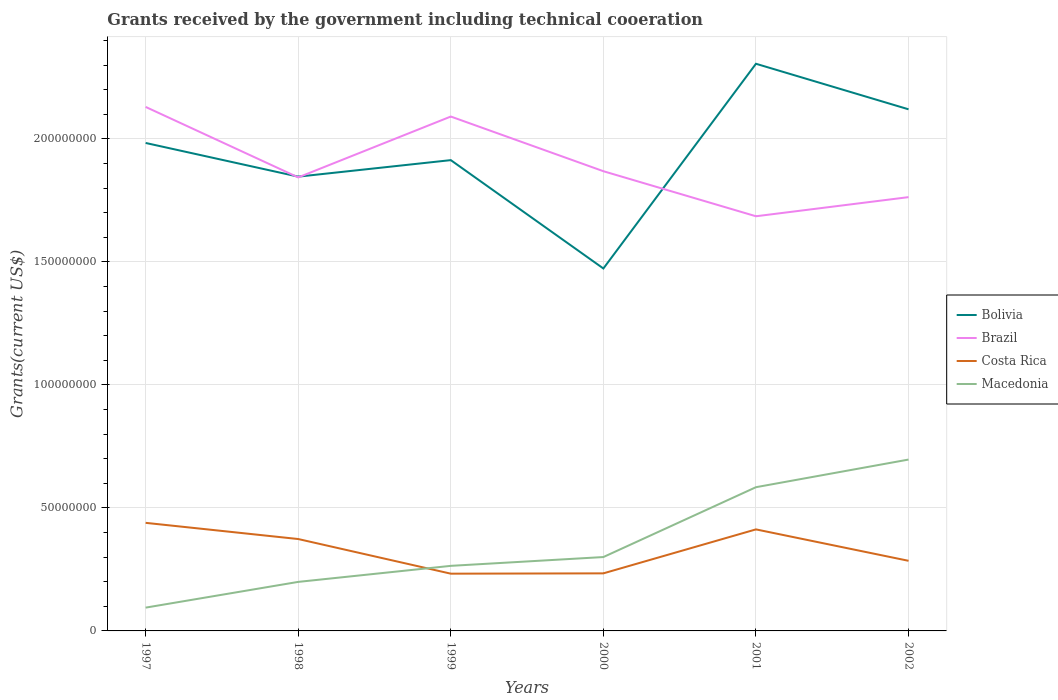Does the line corresponding to Brazil intersect with the line corresponding to Costa Rica?
Keep it short and to the point. No. Across all years, what is the maximum total grants received by the government in Brazil?
Keep it short and to the point. 1.69e+08. In which year was the total grants received by the government in Macedonia maximum?
Your response must be concise. 1997. What is the total total grants received by the government in Costa Rica in the graph?
Offer a very short reply. 1.54e+07. What is the difference between the highest and the second highest total grants received by the government in Costa Rica?
Make the answer very short. 2.07e+07. What is the difference between the highest and the lowest total grants received by the government in Macedonia?
Your answer should be compact. 2. Is the total grants received by the government in Costa Rica strictly greater than the total grants received by the government in Brazil over the years?
Give a very brief answer. Yes. How many lines are there?
Offer a terse response. 4. Are the values on the major ticks of Y-axis written in scientific E-notation?
Provide a short and direct response. No. Does the graph contain any zero values?
Offer a terse response. No. Does the graph contain grids?
Provide a short and direct response. Yes. How many legend labels are there?
Keep it short and to the point. 4. How are the legend labels stacked?
Provide a short and direct response. Vertical. What is the title of the graph?
Your response must be concise. Grants received by the government including technical cooeration. Does "Azerbaijan" appear as one of the legend labels in the graph?
Provide a short and direct response. No. What is the label or title of the X-axis?
Make the answer very short. Years. What is the label or title of the Y-axis?
Give a very brief answer. Grants(current US$). What is the Grants(current US$) in Bolivia in 1997?
Offer a terse response. 1.98e+08. What is the Grants(current US$) of Brazil in 1997?
Provide a succinct answer. 2.13e+08. What is the Grants(current US$) of Costa Rica in 1997?
Offer a very short reply. 4.39e+07. What is the Grants(current US$) of Macedonia in 1997?
Provide a succinct answer. 9.47e+06. What is the Grants(current US$) in Bolivia in 1998?
Provide a succinct answer. 1.85e+08. What is the Grants(current US$) in Brazil in 1998?
Offer a very short reply. 1.84e+08. What is the Grants(current US$) in Costa Rica in 1998?
Your answer should be very brief. 3.74e+07. What is the Grants(current US$) in Macedonia in 1998?
Your answer should be very brief. 1.99e+07. What is the Grants(current US$) in Bolivia in 1999?
Make the answer very short. 1.91e+08. What is the Grants(current US$) of Brazil in 1999?
Offer a terse response. 2.09e+08. What is the Grants(current US$) in Costa Rica in 1999?
Make the answer very short. 2.33e+07. What is the Grants(current US$) of Macedonia in 1999?
Provide a succinct answer. 2.64e+07. What is the Grants(current US$) of Bolivia in 2000?
Make the answer very short. 1.47e+08. What is the Grants(current US$) in Brazil in 2000?
Make the answer very short. 1.87e+08. What is the Grants(current US$) in Costa Rica in 2000?
Provide a short and direct response. 2.34e+07. What is the Grants(current US$) of Macedonia in 2000?
Give a very brief answer. 3.00e+07. What is the Grants(current US$) in Bolivia in 2001?
Offer a very short reply. 2.31e+08. What is the Grants(current US$) of Brazil in 2001?
Give a very brief answer. 1.69e+08. What is the Grants(current US$) of Costa Rica in 2001?
Provide a short and direct response. 4.13e+07. What is the Grants(current US$) of Macedonia in 2001?
Offer a very short reply. 5.84e+07. What is the Grants(current US$) of Bolivia in 2002?
Your response must be concise. 2.12e+08. What is the Grants(current US$) in Brazil in 2002?
Make the answer very short. 1.76e+08. What is the Grants(current US$) in Costa Rica in 2002?
Provide a succinct answer. 2.85e+07. What is the Grants(current US$) in Macedonia in 2002?
Provide a succinct answer. 6.96e+07. Across all years, what is the maximum Grants(current US$) of Bolivia?
Your answer should be compact. 2.31e+08. Across all years, what is the maximum Grants(current US$) of Brazil?
Ensure brevity in your answer.  2.13e+08. Across all years, what is the maximum Grants(current US$) in Costa Rica?
Offer a very short reply. 4.39e+07. Across all years, what is the maximum Grants(current US$) in Macedonia?
Provide a short and direct response. 6.96e+07. Across all years, what is the minimum Grants(current US$) in Bolivia?
Give a very brief answer. 1.47e+08. Across all years, what is the minimum Grants(current US$) of Brazil?
Provide a succinct answer. 1.69e+08. Across all years, what is the minimum Grants(current US$) of Costa Rica?
Offer a terse response. 2.33e+07. Across all years, what is the minimum Grants(current US$) of Macedonia?
Provide a succinct answer. 9.47e+06. What is the total Grants(current US$) in Bolivia in the graph?
Ensure brevity in your answer.  1.16e+09. What is the total Grants(current US$) of Brazil in the graph?
Make the answer very short. 1.14e+09. What is the total Grants(current US$) of Costa Rica in the graph?
Offer a very short reply. 1.98e+08. What is the total Grants(current US$) of Macedonia in the graph?
Make the answer very short. 2.14e+08. What is the difference between the Grants(current US$) in Bolivia in 1997 and that in 1998?
Make the answer very short. 1.37e+07. What is the difference between the Grants(current US$) in Brazil in 1997 and that in 1998?
Give a very brief answer. 2.86e+07. What is the difference between the Grants(current US$) of Costa Rica in 1997 and that in 1998?
Make the answer very short. 6.58e+06. What is the difference between the Grants(current US$) in Macedonia in 1997 and that in 1998?
Give a very brief answer. -1.05e+07. What is the difference between the Grants(current US$) in Bolivia in 1997 and that in 1999?
Give a very brief answer. 6.98e+06. What is the difference between the Grants(current US$) in Brazil in 1997 and that in 1999?
Keep it short and to the point. 3.91e+06. What is the difference between the Grants(current US$) in Costa Rica in 1997 and that in 1999?
Make the answer very short. 2.07e+07. What is the difference between the Grants(current US$) in Macedonia in 1997 and that in 1999?
Offer a very short reply. -1.70e+07. What is the difference between the Grants(current US$) in Bolivia in 1997 and that in 2000?
Provide a succinct answer. 5.10e+07. What is the difference between the Grants(current US$) of Brazil in 1997 and that in 2000?
Your response must be concise. 2.61e+07. What is the difference between the Grants(current US$) in Costa Rica in 1997 and that in 2000?
Offer a terse response. 2.05e+07. What is the difference between the Grants(current US$) of Macedonia in 1997 and that in 2000?
Give a very brief answer. -2.06e+07. What is the difference between the Grants(current US$) in Bolivia in 1997 and that in 2001?
Provide a short and direct response. -3.22e+07. What is the difference between the Grants(current US$) in Brazil in 1997 and that in 2001?
Make the answer very short. 4.44e+07. What is the difference between the Grants(current US$) in Costa Rica in 1997 and that in 2001?
Give a very brief answer. 2.66e+06. What is the difference between the Grants(current US$) in Macedonia in 1997 and that in 2001?
Give a very brief answer. -4.90e+07. What is the difference between the Grants(current US$) in Bolivia in 1997 and that in 2002?
Ensure brevity in your answer.  -1.37e+07. What is the difference between the Grants(current US$) in Brazil in 1997 and that in 2002?
Offer a terse response. 3.67e+07. What is the difference between the Grants(current US$) of Costa Rica in 1997 and that in 2002?
Give a very brief answer. 1.54e+07. What is the difference between the Grants(current US$) in Macedonia in 1997 and that in 2002?
Provide a succinct answer. -6.02e+07. What is the difference between the Grants(current US$) of Bolivia in 1998 and that in 1999?
Give a very brief answer. -6.71e+06. What is the difference between the Grants(current US$) of Brazil in 1998 and that in 1999?
Make the answer very short. -2.47e+07. What is the difference between the Grants(current US$) of Costa Rica in 1998 and that in 1999?
Your response must be concise. 1.41e+07. What is the difference between the Grants(current US$) in Macedonia in 1998 and that in 1999?
Keep it short and to the point. -6.52e+06. What is the difference between the Grants(current US$) in Bolivia in 1998 and that in 2000?
Your response must be concise. 3.73e+07. What is the difference between the Grants(current US$) in Brazil in 1998 and that in 2000?
Make the answer very short. -2.52e+06. What is the difference between the Grants(current US$) of Costa Rica in 1998 and that in 2000?
Provide a short and direct response. 1.40e+07. What is the difference between the Grants(current US$) in Macedonia in 1998 and that in 2000?
Provide a short and direct response. -1.01e+07. What is the difference between the Grants(current US$) of Bolivia in 1998 and that in 2001?
Your answer should be very brief. -4.59e+07. What is the difference between the Grants(current US$) in Brazil in 1998 and that in 2001?
Provide a succinct answer. 1.58e+07. What is the difference between the Grants(current US$) of Costa Rica in 1998 and that in 2001?
Offer a terse response. -3.92e+06. What is the difference between the Grants(current US$) in Macedonia in 1998 and that in 2001?
Keep it short and to the point. -3.85e+07. What is the difference between the Grants(current US$) in Bolivia in 1998 and that in 2002?
Provide a succinct answer. -2.74e+07. What is the difference between the Grants(current US$) of Brazil in 1998 and that in 2002?
Your answer should be compact. 8.02e+06. What is the difference between the Grants(current US$) of Costa Rica in 1998 and that in 2002?
Offer a very short reply. 8.85e+06. What is the difference between the Grants(current US$) in Macedonia in 1998 and that in 2002?
Make the answer very short. -4.97e+07. What is the difference between the Grants(current US$) of Bolivia in 1999 and that in 2000?
Keep it short and to the point. 4.40e+07. What is the difference between the Grants(current US$) in Brazil in 1999 and that in 2000?
Your response must be concise. 2.22e+07. What is the difference between the Grants(current US$) of Costa Rica in 1999 and that in 2000?
Provide a succinct answer. -1.30e+05. What is the difference between the Grants(current US$) of Macedonia in 1999 and that in 2000?
Ensure brevity in your answer.  -3.58e+06. What is the difference between the Grants(current US$) of Bolivia in 1999 and that in 2001?
Provide a short and direct response. -3.92e+07. What is the difference between the Grants(current US$) of Brazil in 1999 and that in 2001?
Your answer should be compact. 4.05e+07. What is the difference between the Grants(current US$) of Costa Rica in 1999 and that in 2001?
Your answer should be very brief. -1.80e+07. What is the difference between the Grants(current US$) in Macedonia in 1999 and that in 2001?
Ensure brevity in your answer.  -3.20e+07. What is the difference between the Grants(current US$) of Bolivia in 1999 and that in 2002?
Offer a terse response. -2.07e+07. What is the difference between the Grants(current US$) in Brazil in 1999 and that in 2002?
Keep it short and to the point. 3.28e+07. What is the difference between the Grants(current US$) of Costa Rica in 1999 and that in 2002?
Your response must be concise. -5.23e+06. What is the difference between the Grants(current US$) of Macedonia in 1999 and that in 2002?
Provide a succinct answer. -4.32e+07. What is the difference between the Grants(current US$) in Bolivia in 2000 and that in 2001?
Give a very brief answer. -8.32e+07. What is the difference between the Grants(current US$) in Brazil in 2000 and that in 2001?
Ensure brevity in your answer.  1.83e+07. What is the difference between the Grants(current US$) of Costa Rica in 2000 and that in 2001?
Offer a very short reply. -1.79e+07. What is the difference between the Grants(current US$) of Macedonia in 2000 and that in 2001?
Keep it short and to the point. -2.84e+07. What is the difference between the Grants(current US$) of Bolivia in 2000 and that in 2002?
Offer a terse response. -6.47e+07. What is the difference between the Grants(current US$) of Brazil in 2000 and that in 2002?
Your answer should be very brief. 1.05e+07. What is the difference between the Grants(current US$) of Costa Rica in 2000 and that in 2002?
Your answer should be very brief. -5.10e+06. What is the difference between the Grants(current US$) in Macedonia in 2000 and that in 2002?
Keep it short and to the point. -3.96e+07. What is the difference between the Grants(current US$) in Bolivia in 2001 and that in 2002?
Provide a short and direct response. 1.85e+07. What is the difference between the Grants(current US$) of Brazil in 2001 and that in 2002?
Your answer should be very brief. -7.77e+06. What is the difference between the Grants(current US$) of Costa Rica in 2001 and that in 2002?
Make the answer very short. 1.28e+07. What is the difference between the Grants(current US$) in Macedonia in 2001 and that in 2002?
Give a very brief answer. -1.12e+07. What is the difference between the Grants(current US$) in Bolivia in 1997 and the Grants(current US$) in Brazil in 1998?
Give a very brief answer. 1.40e+07. What is the difference between the Grants(current US$) of Bolivia in 1997 and the Grants(current US$) of Costa Rica in 1998?
Make the answer very short. 1.61e+08. What is the difference between the Grants(current US$) of Bolivia in 1997 and the Grants(current US$) of Macedonia in 1998?
Make the answer very short. 1.78e+08. What is the difference between the Grants(current US$) in Brazil in 1997 and the Grants(current US$) in Costa Rica in 1998?
Offer a very short reply. 1.76e+08. What is the difference between the Grants(current US$) of Brazil in 1997 and the Grants(current US$) of Macedonia in 1998?
Keep it short and to the point. 1.93e+08. What is the difference between the Grants(current US$) of Costa Rica in 1997 and the Grants(current US$) of Macedonia in 1998?
Your response must be concise. 2.40e+07. What is the difference between the Grants(current US$) in Bolivia in 1997 and the Grants(current US$) in Brazil in 1999?
Your response must be concise. -1.07e+07. What is the difference between the Grants(current US$) of Bolivia in 1997 and the Grants(current US$) of Costa Rica in 1999?
Keep it short and to the point. 1.75e+08. What is the difference between the Grants(current US$) in Bolivia in 1997 and the Grants(current US$) in Macedonia in 1999?
Your response must be concise. 1.72e+08. What is the difference between the Grants(current US$) in Brazil in 1997 and the Grants(current US$) in Costa Rica in 1999?
Give a very brief answer. 1.90e+08. What is the difference between the Grants(current US$) in Brazil in 1997 and the Grants(current US$) in Macedonia in 1999?
Your answer should be compact. 1.87e+08. What is the difference between the Grants(current US$) of Costa Rica in 1997 and the Grants(current US$) of Macedonia in 1999?
Your response must be concise. 1.75e+07. What is the difference between the Grants(current US$) in Bolivia in 1997 and the Grants(current US$) in Brazil in 2000?
Your answer should be very brief. 1.15e+07. What is the difference between the Grants(current US$) in Bolivia in 1997 and the Grants(current US$) in Costa Rica in 2000?
Provide a succinct answer. 1.75e+08. What is the difference between the Grants(current US$) of Bolivia in 1997 and the Grants(current US$) of Macedonia in 2000?
Ensure brevity in your answer.  1.68e+08. What is the difference between the Grants(current US$) in Brazil in 1997 and the Grants(current US$) in Costa Rica in 2000?
Ensure brevity in your answer.  1.90e+08. What is the difference between the Grants(current US$) of Brazil in 1997 and the Grants(current US$) of Macedonia in 2000?
Offer a terse response. 1.83e+08. What is the difference between the Grants(current US$) in Costa Rica in 1997 and the Grants(current US$) in Macedonia in 2000?
Ensure brevity in your answer.  1.39e+07. What is the difference between the Grants(current US$) of Bolivia in 1997 and the Grants(current US$) of Brazil in 2001?
Make the answer very short. 2.98e+07. What is the difference between the Grants(current US$) of Bolivia in 1997 and the Grants(current US$) of Costa Rica in 2001?
Provide a succinct answer. 1.57e+08. What is the difference between the Grants(current US$) in Bolivia in 1997 and the Grants(current US$) in Macedonia in 2001?
Make the answer very short. 1.40e+08. What is the difference between the Grants(current US$) of Brazil in 1997 and the Grants(current US$) of Costa Rica in 2001?
Your answer should be compact. 1.72e+08. What is the difference between the Grants(current US$) in Brazil in 1997 and the Grants(current US$) in Macedonia in 2001?
Give a very brief answer. 1.55e+08. What is the difference between the Grants(current US$) in Costa Rica in 1997 and the Grants(current US$) in Macedonia in 2001?
Provide a short and direct response. -1.45e+07. What is the difference between the Grants(current US$) of Bolivia in 1997 and the Grants(current US$) of Brazil in 2002?
Offer a terse response. 2.20e+07. What is the difference between the Grants(current US$) of Bolivia in 1997 and the Grants(current US$) of Costa Rica in 2002?
Ensure brevity in your answer.  1.70e+08. What is the difference between the Grants(current US$) in Bolivia in 1997 and the Grants(current US$) in Macedonia in 2002?
Provide a short and direct response. 1.29e+08. What is the difference between the Grants(current US$) in Brazil in 1997 and the Grants(current US$) in Costa Rica in 2002?
Offer a very short reply. 1.84e+08. What is the difference between the Grants(current US$) in Brazil in 1997 and the Grants(current US$) in Macedonia in 2002?
Provide a short and direct response. 1.43e+08. What is the difference between the Grants(current US$) in Costa Rica in 1997 and the Grants(current US$) in Macedonia in 2002?
Your response must be concise. -2.57e+07. What is the difference between the Grants(current US$) in Bolivia in 1998 and the Grants(current US$) in Brazil in 1999?
Provide a short and direct response. -2.44e+07. What is the difference between the Grants(current US$) in Bolivia in 1998 and the Grants(current US$) in Costa Rica in 1999?
Offer a terse response. 1.61e+08. What is the difference between the Grants(current US$) of Bolivia in 1998 and the Grants(current US$) of Macedonia in 1999?
Ensure brevity in your answer.  1.58e+08. What is the difference between the Grants(current US$) of Brazil in 1998 and the Grants(current US$) of Costa Rica in 1999?
Offer a very short reply. 1.61e+08. What is the difference between the Grants(current US$) in Brazil in 1998 and the Grants(current US$) in Macedonia in 1999?
Give a very brief answer. 1.58e+08. What is the difference between the Grants(current US$) of Costa Rica in 1998 and the Grants(current US$) of Macedonia in 1999?
Ensure brevity in your answer.  1.09e+07. What is the difference between the Grants(current US$) of Bolivia in 1998 and the Grants(current US$) of Brazil in 2000?
Keep it short and to the point. -2.21e+06. What is the difference between the Grants(current US$) in Bolivia in 1998 and the Grants(current US$) in Costa Rica in 2000?
Provide a succinct answer. 1.61e+08. What is the difference between the Grants(current US$) in Bolivia in 1998 and the Grants(current US$) in Macedonia in 2000?
Your answer should be compact. 1.55e+08. What is the difference between the Grants(current US$) in Brazil in 1998 and the Grants(current US$) in Costa Rica in 2000?
Your response must be concise. 1.61e+08. What is the difference between the Grants(current US$) in Brazil in 1998 and the Grants(current US$) in Macedonia in 2000?
Ensure brevity in your answer.  1.54e+08. What is the difference between the Grants(current US$) in Costa Rica in 1998 and the Grants(current US$) in Macedonia in 2000?
Keep it short and to the point. 7.32e+06. What is the difference between the Grants(current US$) of Bolivia in 1998 and the Grants(current US$) of Brazil in 2001?
Provide a short and direct response. 1.61e+07. What is the difference between the Grants(current US$) of Bolivia in 1998 and the Grants(current US$) of Costa Rica in 2001?
Ensure brevity in your answer.  1.43e+08. What is the difference between the Grants(current US$) of Bolivia in 1998 and the Grants(current US$) of Macedonia in 2001?
Keep it short and to the point. 1.26e+08. What is the difference between the Grants(current US$) of Brazil in 1998 and the Grants(current US$) of Costa Rica in 2001?
Give a very brief answer. 1.43e+08. What is the difference between the Grants(current US$) in Brazil in 1998 and the Grants(current US$) in Macedonia in 2001?
Keep it short and to the point. 1.26e+08. What is the difference between the Grants(current US$) of Costa Rica in 1998 and the Grants(current US$) of Macedonia in 2001?
Provide a succinct answer. -2.11e+07. What is the difference between the Grants(current US$) of Bolivia in 1998 and the Grants(current US$) of Brazil in 2002?
Give a very brief answer. 8.33e+06. What is the difference between the Grants(current US$) in Bolivia in 1998 and the Grants(current US$) in Costa Rica in 2002?
Your answer should be compact. 1.56e+08. What is the difference between the Grants(current US$) of Bolivia in 1998 and the Grants(current US$) of Macedonia in 2002?
Your answer should be compact. 1.15e+08. What is the difference between the Grants(current US$) in Brazil in 1998 and the Grants(current US$) in Costa Rica in 2002?
Provide a succinct answer. 1.56e+08. What is the difference between the Grants(current US$) in Brazil in 1998 and the Grants(current US$) in Macedonia in 2002?
Ensure brevity in your answer.  1.15e+08. What is the difference between the Grants(current US$) of Costa Rica in 1998 and the Grants(current US$) of Macedonia in 2002?
Provide a short and direct response. -3.23e+07. What is the difference between the Grants(current US$) of Bolivia in 1999 and the Grants(current US$) of Brazil in 2000?
Keep it short and to the point. 4.50e+06. What is the difference between the Grants(current US$) in Bolivia in 1999 and the Grants(current US$) in Costa Rica in 2000?
Give a very brief answer. 1.68e+08. What is the difference between the Grants(current US$) in Bolivia in 1999 and the Grants(current US$) in Macedonia in 2000?
Ensure brevity in your answer.  1.61e+08. What is the difference between the Grants(current US$) in Brazil in 1999 and the Grants(current US$) in Costa Rica in 2000?
Your answer should be compact. 1.86e+08. What is the difference between the Grants(current US$) in Brazil in 1999 and the Grants(current US$) in Macedonia in 2000?
Keep it short and to the point. 1.79e+08. What is the difference between the Grants(current US$) of Costa Rica in 1999 and the Grants(current US$) of Macedonia in 2000?
Provide a short and direct response. -6.76e+06. What is the difference between the Grants(current US$) of Bolivia in 1999 and the Grants(current US$) of Brazil in 2001?
Provide a short and direct response. 2.28e+07. What is the difference between the Grants(current US$) of Bolivia in 1999 and the Grants(current US$) of Costa Rica in 2001?
Give a very brief answer. 1.50e+08. What is the difference between the Grants(current US$) of Bolivia in 1999 and the Grants(current US$) of Macedonia in 2001?
Ensure brevity in your answer.  1.33e+08. What is the difference between the Grants(current US$) of Brazil in 1999 and the Grants(current US$) of Costa Rica in 2001?
Provide a succinct answer. 1.68e+08. What is the difference between the Grants(current US$) of Brazil in 1999 and the Grants(current US$) of Macedonia in 2001?
Keep it short and to the point. 1.51e+08. What is the difference between the Grants(current US$) of Costa Rica in 1999 and the Grants(current US$) of Macedonia in 2001?
Your answer should be very brief. -3.52e+07. What is the difference between the Grants(current US$) in Bolivia in 1999 and the Grants(current US$) in Brazil in 2002?
Provide a short and direct response. 1.50e+07. What is the difference between the Grants(current US$) of Bolivia in 1999 and the Grants(current US$) of Costa Rica in 2002?
Offer a terse response. 1.63e+08. What is the difference between the Grants(current US$) of Bolivia in 1999 and the Grants(current US$) of Macedonia in 2002?
Ensure brevity in your answer.  1.22e+08. What is the difference between the Grants(current US$) in Brazil in 1999 and the Grants(current US$) in Costa Rica in 2002?
Offer a very short reply. 1.81e+08. What is the difference between the Grants(current US$) in Brazil in 1999 and the Grants(current US$) in Macedonia in 2002?
Your response must be concise. 1.39e+08. What is the difference between the Grants(current US$) of Costa Rica in 1999 and the Grants(current US$) of Macedonia in 2002?
Provide a succinct answer. -4.64e+07. What is the difference between the Grants(current US$) in Bolivia in 2000 and the Grants(current US$) in Brazil in 2001?
Provide a short and direct response. -2.12e+07. What is the difference between the Grants(current US$) of Bolivia in 2000 and the Grants(current US$) of Costa Rica in 2001?
Ensure brevity in your answer.  1.06e+08. What is the difference between the Grants(current US$) in Bolivia in 2000 and the Grants(current US$) in Macedonia in 2001?
Give a very brief answer. 8.89e+07. What is the difference between the Grants(current US$) of Brazil in 2000 and the Grants(current US$) of Costa Rica in 2001?
Your answer should be compact. 1.46e+08. What is the difference between the Grants(current US$) in Brazil in 2000 and the Grants(current US$) in Macedonia in 2001?
Your answer should be very brief. 1.28e+08. What is the difference between the Grants(current US$) of Costa Rica in 2000 and the Grants(current US$) of Macedonia in 2001?
Offer a very short reply. -3.50e+07. What is the difference between the Grants(current US$) of Bolivia in 2000 and the Grants(current US$) of Brazil in 2002?
Your answer should be compact. -2.90e+07. What is the difference between the Grants(current US$) in Bolivia in 2000 and the Grants(current US$) in Costa Rica in 2002?
Your answer should be very brief. 1.19e+08. What is the difference between the Grants(current US$) in Bolivia in 2000 and the Grants(current US$) in Macedonia in 2002?
Keep it short and to the point. 7.77e+07. What is the difference between the Grants(current US$) in Brazil in 2000 and the Grants(current US$) in Costa Rica in 2002?
Make the answer very short. 1.58e+08. What is the difference between the Grants(current US$) of Brazil in 2000 and the Grants(current US$) of Macedonia in 2002?
Provide a succinct answer. 1.17e+08. What is the difference between the Grants(current US$) of Costa Rica in 2000 and the Grants(current US$) of Macedonia in 2002?
Your answer should be very brief. -4.62e+07. What is the difference between the Grants(current US$) in Bolivia in 2001 and the Grants(current US$) in Brazil in 2002?
Make the answer very short. 5.42e+07. What is the difference between the Grants(current US$) in Bolivia in 2001 and the Grants(current US$) in Costa Rica in 2002?
Give a very brief answer. 2.02e+08. What is the difference between the Grants(current US$) in Bolivia in 2001 and the Grants(current US$) in Macedonia in 2002?
Offer a terse response. 1.61e+08. What is the difference between the Grants(current US$) in Brazil in 2001 and the Grants(current US$) in Costa Rica in 2002?
Offer a very short reply. 1.40e+08. What is the difference between the Grants(current US$) of Brazil in 2001 and the Grants(current US$) of Macedonia in 2002?
Make the answer very short. 9.89e+07. What is the difference between the Grants(current US$) of Costa Rica in 2001 and the Grants(current US$) of Macedonia in 2002?
Your answer should be very brief. -2.84e+07. What is the average Grants(current US$) of Bolivia per year?
Ensure brevity in your answer.  1.94e+08. What is the average Grants(current US$) in Brazil per year?
Ensure brevity in your answer.  1.90e+08. What is the average Grants(current US$) in Costa Rica per year?
Your response must be concise. 3.30e+07. What is the average Grants(current US$) of Macedonia per year?
Keep it short and to the point. 3.57e+07. In the year 1997, what is the difference between the Grants(current US$) in Bolivia and Grants(current US$) in Brazil?
Your response must be concise. -1.46e+07. In the year 1997, what is the difference between the Grants(current US$) in Bolivia and Grants(current US$) in Costa Rica?
Your answer should be compact. 1.54e+08. In the year 1997, what is the difference between the Grants(current US$) of Bolivia and Grants(current US$) of Macedonia?
Make the answer very short. 1.89e+08. In the year 1997, what is the difference between the Grants(current US$) of Brazil and Grants(current US$) of Costa Rica?
Offer a very short reply. 1.69e+08. In the year 1997, what is the difference between the Grants(current US$) of Brazil and Grants(current US$) of Macedonia?
Your answer should be compact. 2.04e+08. In the year 1997, what is the difference between the Grants(current US$) in Costa Rica and Grants(current US$) in Macedonia?
Give a very brief answer. 3.45e+07. In the year 1998, what is the difference between the Grants(current US$) of Bolivia and Grants(current US$) of Costa Rica?
Ensure brevity in your answer.  1.47e+08. In the year 1998, what is the difference between the Grants(current US$) in Bolivia and Grants(current US$) in Macedonia?
Keep it short and to the point. 1.65e+08. In the year 1998, what is the difference between the Grants(current US$) of Brazil and Grants(current US$) of Costa Rica?
Give a very brief answer. 1.47e+08. In the year 1998, what is the difference between the Grants(current US$) in Brazil and Grants(current US$) in Macedonia?
Give a very brief answer. 1.64e+08. In the year 1998, what is the difference between the Grants(current US$) of Costa Rica and Grants(current US$) of Macedonia?
Your answer should be very brief. 1.74e+07. In the year 1999, what is the difference between the Grants(current US$) in Bolivia and Grants(current US$) in Brazil?
Provide a short and direct response. -1.77e+07. In the year 1999, what is the difference between the Grants(current US$) in Bolivia and Grants(current US$) in Costa Rica?
Offer a very short reply. 1.68e+08. In the year 1999, what is the difference between the Grants(current US$) of Bolivia and Grants(current US$) of Macedonia?
Offer a very short reply. 1.65e+08. In the year 1999, what is the difference between the Grants(current US$) in Brazil and Grants(current US$) in Costa Rica?
Provide a succinct answer. 1.86e+08. In the year 1999, what is the difference between the Grants(current US$) of Brazil and Grants(current US$) of Macedonia?
Provide a short and direct response. 1.83e+08. In the year 1999, what is the difference between the Grants(current US$) in Costa Rica and Grants(current US$) in Macedonia?
Give a very brief answer. -3.18e+06. In the year 2000, what is the difference between the Grants(current US$) of Bolivia and Grants(current US$) of Brazil?
Provide a short and direct response. -3.95e+07. In the year 2000, what is the difference between the Grants(current US$) of Bolivia and Grants(current US$) of Costa Rica?
Give a very brief answer. 1.24e+08. In the year 2000, what is the difference between the Grants(current US$) of Bolivia and Grants(current US$) of Macedonia?
Provide a short and direct response. 1.17e+08. In the year 2000, what is the difference between the Grants(current US$) of Brazil and Grants(current US$) of Costa Rica?
Offer a terse response. 1.63e+08. In the year 2000, what is the difference between the Grants(current US$) in Brazil and Grants(current US$) in Macedonia?
Make the answer very short. 1.57e+08. In the year 2000, what is the difference between the Grants(current US$) in Costa Rica and Grants(current US$) in Macedonia?
Provide a succinct answer. -6.63e+06. In the year 2001, what is the difference between the Grants(current US$) in Bolivia and Grants(current US$) in Brazil?
Offer a very short reply. 6.20e+07. In the year 2001, what is the difference between the Grants(current US$) in Bolivia and Grants(current US$) in Costa Rica?
Your answer should be very brief. 1.89e+08. In the year 2001, what is the difference between the Grants(current US$) of Bolivia and Grants(current US$) of Macedonia?
Offer a terse response. 1.72e+08. In the year 2001, what is the difference between the Grants(current US$) in Brazil and Grants(current US$) in Costa Rica?
Offer a very short reply. 1.27e+08. In the year 2001, what is the difference between the Grants(current US$) of Brazil and Grants(current US$) of Macedonia?
Make the answer very short. 1.10e+08. In the year 2001, what is the difference between the Grants(current US$) in Costa Rica and Grants(current US$) in Macedonia?
Provide a short and direct response. -1.72e+07. In the year 2002, what is the difference between the Grants(current US$) of Bolivia and Grants(current US$) of Brazil?
Offer a very short reply. 3.57e+07. In the year 2002, what is the difference between the Grants(current US$) of Bolivia and Grants(current US$) of Costa Rica?
Give a very brief answer. 1.84e+08. In the year 2002, what is the difference between the Grants(current US$) of Bolivia and Grants(current US$) of Macedonia?
Keep it short and to the point. 1.42e+08. In the year 2002, what is the difference between the Grants(current US$) of Brazil and Grants(current US$) of Costa Rica?
Offer a terse response. 1.48e+08. In the year 2002, what is the difference between the Grants(current US$) in Brazil and Grants(current US$) in Macedonia?
Your response must be concise. 1.07e+08. In the year 2002, what is the difference between the Grants(current US$) in Costa Rica and Grants(current US$) in Macedonia?
Offer a very short reply. -4.12e+07. What is the ratio of the Grants(current US$) of Bolivia in 1997 to that in 1998?
Your answer should be compact. 1.07. What is the ratio of the Grants(current US$) of Brazil in 1997 to that in 1998?
Give a very brief answer. 1.16. What is the ratio of the Grants(current US$) in Costa Rica in 1997 to that in 1998?
Keep it short and to the point. 1.18. What is the ratio of the Grants(current US$) in Macedonia in 1997 to that in 1998?
Keep it short and to the point. 0.48. What is the ratio of the Grants(current US$) in Bolivia in 1997 to that in 1999?
Provide a short and direct response. 1.04. What is the ratio of the Grants(current US$) in Brazil in 1997 to that in 1999?
Keep it short and to the point. 1.02. What is the ratio of the Grants(current US$) in Costa Rica in 1997 to that in 1999?
Your answer should be compact. 1.89. What is the ratio of the Grants(current US$) of Macedonia in 1997 to that in 1999?
Make the answer very short. 0.36. What is the ratio of the Grants(current US$) of Bolivia in 1997 to that in 2000?
Offer a very short reply. 1.35. What is the ratio of the Grants(current US$) in Brazil in 1997 to that in 2000?
Make the answer very short. 1.14. What is the ratio of the Grants(current US$) in Costa Rica in 1997 to that in 2000?
Ensure brevity in your answer.  1.88. What is the ratio of the Grants(current US$) of Macedonia in 1997 to that in 2000?
Ensure brevity in your answer.  0.32. What is the ratio of the Grants(current US$) in Bolivia in 1997 to that in 2001?
Your answer should be very brief. 0.86. What is the ratio of the Grants(current US$) in Brazil in 1997 to that in 2001?
Your answer should be very brief. 1.26. What is the ratio of the Grants(current US$) of Costa Rica in 1997 to that in 2001?
Your response must be concise. 1.06. What is the ratio of the Grants(current US$) in Macedonia in 1997 to that in 2001?
Offer a very short reply. 0.16. What is the ratio of the Grants(current US$) in Bolivia in 1997 to that in 2002?
Ensure brevity in your answer.  0.94. What is the ratio of the Grants(current US$) of Brazil in 1997 to that in 2002?
Give a very brief answer. 1.21. What is the ratio of the Grants(current US$) of Costa Rica in 1997 to that in 2002?
Your answer should be very brief. 1.54. What is the ratio of the Grants(current US$) in Macedonia in 1997 to that in 2002?
Keep it short and to the point. 0.14. What is the ratio of the Grants(current US$) in Bolivia in 1998 to that in 1999?
Provide a succinct answer. 0.96. What is the ratio of the Grants(current US$) in Brazil in 1998 to that in 1999?
Offer a very short reply. 0.88. What is the ratio of the Grants(current US$) of Costa Rica in 1998 to that in 1999?
Your answer should be very brief. 1.61. What is the ratio of the Grants(current US$) in Macedonia in 1998 to that in 1999?
Ensure brevity in your answer.  0.75. What is the ratio of the Grants(current US$) in Bolivia in 1998 to that in 2000?
Your answer should be compact. 1.25. What is the ratio of the Grants(current US$) in Brazil in 1998 to that in 2000?
Your answer should be very brief. 0.99. What is the ratio of the Grants(current US$) of Costa Rica in 1998 to that in 2000?
Your answer should be compact. 1.6. What is the ratio of the Grants(current US$) in Macedonia in 1998 to that in 2000?
Your response must be concise. 0.66. What is the ratio of the Grants(current US$) in Bolivia in 1998 to that in 2001?
Ensure brevity in your answer.  0.8. What is the ratio of the Grants(current US$) in Brazil in 1998 to that in 2001?
Offer a terse response. 1.09. What is the ratio of the Grants(current US$) of Costa Rica in 1998 to that in 2001?
Offer a terse response. 0.91. What is the ratio of the Grants(current US$) in Macedonia in 1998 to that in 2001?
Your answer should be compact. 0.34. What is the ratio of the Grants(current US$) of Bolivia in 1998 to that in 2002?
Keep it short and to the point. 0.87. What is the ratio of the Grants(current US$) in Brazil in 1998 to that in 2002?
Provide a short and direct response. 1.05. What is the ratio of the Grants(current US$) in Costa Rica in 1998 to that in 2002?
Keep it short and to the point. 1.31. What is the ratio of the Grants(current US$) in Macedonia in 1998 to that in 2002?
Ensure brevity in your answer.  0.29. What is the ratio of the Grants(current US$) in Bolivia in 1999 to that in 2000?
Keep it short and to the point. 1.3. What is the ratio of the Grants(current US$) in Brazil in 1999 to that in 2000?
Offer a terse response. 1.12. What is the ratio of the Grants(current US$) of Macedonia in 1999 to that in 2000?
Make the answer very short. 0.88. What is the ratio of the Grants(current US$) in Bolivia in 1999 to that in 2001?
Give a very brief answer. 0.83. What is the ratio of the Grants(current US$) of Brazil in 1999 to that in 2001?
Your response must be concise. 1.24. What is the ratio of the Grants(current US$) of Costa Rica in 1999 to that in 2001?
Give a very brief answer. 0.56. What is the ratio of the Grants(current US$) in Macedonia in 1999 to that in 2001?
Give a very brief answer. 0.45. What is the ratio of the Grants(current US$) in Bolivia in 1999 to that in 2002?
Give a very brief answer. 0.9. What is the ratio of the Grants(current US$) in Brazil in 1999 to that in 2002?
Keep it short and to the point. 1.19. What is the ratio of the Grants(current US$) of Costa Rica in 1999 to that in 2002?
Provide a short and direct response. 0.82. What is the ratio of the Grants(current US$) in Macedonia in 1999 to that in 2002?
Your answer should be very brief. 0.38. What is the ratio of the Grants(current US$) of Bolivia in 2000 to that in 2001?
Keep it short and to the point. 0.64. What is the ratio of the Grants(current US$) in Brazil in 2000 to that in 2001?
Provide a short and direct response. 1.11. What is the ratio of the Grants(current US$) in Costa Rica in 2000 to that in 2001?
Your response must be concise. 0.57. What is the ratio of the Grants(current US$) in Macedonia in 2000 to that in 2001?
Give a very brief answer. 0.51. What is the ratio of the Grants(current US$) of Bolivia in 2000 to that in 2002?
Provide a short and direct response. 0.69. What is the ratio of the Grants(current US$) of Brazil in 2000 to that in 2002?
Provide a short and direct response. 1.06. What is the ratio of the Grants(current US$) of Costa Rica in 2000 to that in 2002?
Provide a short and direct response. 0.82. What is the ratio of the Grants(current US$) of Macedonia in 2000 to that in 2002?
Offer a very short reply. 0.43. What is the ratio of the Grants(current US$) of Bolivia in 2001 to that in 2002?
Your response must be concise. 1.09. What is the ratio of the Grants(current US$) in Brazil in 2001 to that in 2002?
Provide a succinct answer. 0.96. What is the ratio of the Grants(current US$) of Costa Rica in 2001 to that in 2002?
Give a very brief answer. 1.45. What is the ratio of the Grants(current US$) in Macedonia in 2001 to that in 2002?
Your answer should be compact. 0.84. What is the difference between the highest and the second highest Grants(current US$) of Bolivia?
Offer a very short reply. 1.85e+07. What is the difference between the highest and the second highest Grants(current US$) of Brazil?
Your answer should be compact. 3.91e+06. What is the difference between the highest and the second highest Grants(current US$) in Costa Rica?
Make the answer very short. 2.66e+06. What is the difference between the highest and the second highest Grants(current US$) in Macedonia?
Offer a very short reply. 1.12e+07. What is the difference between the highest and the lowest Grants(current US$) of Bolivia?
Offer a terse response. 8.32e+07. What is the difference between the highest and the lowest Grants(current US$) of Brazil?
Ensure brevity in your answer.  4.44e+07. What is the difference between the highest and the lowest Grants(current US$) of Costa Rica?
Ensure brevity in your answer.  2.07e+07. What is the difference between the highest and the lowest Grants(current US$) in Macedonia?
Provide a succinct answer. 6.02e+07. 